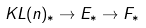Convert formula to latex. <formula><loc_0><loc_0><loc_500><loc_500>K L ( n ) _ { * } \rightarrow E _ { * } \rightarrow F _ { * }</formula> 